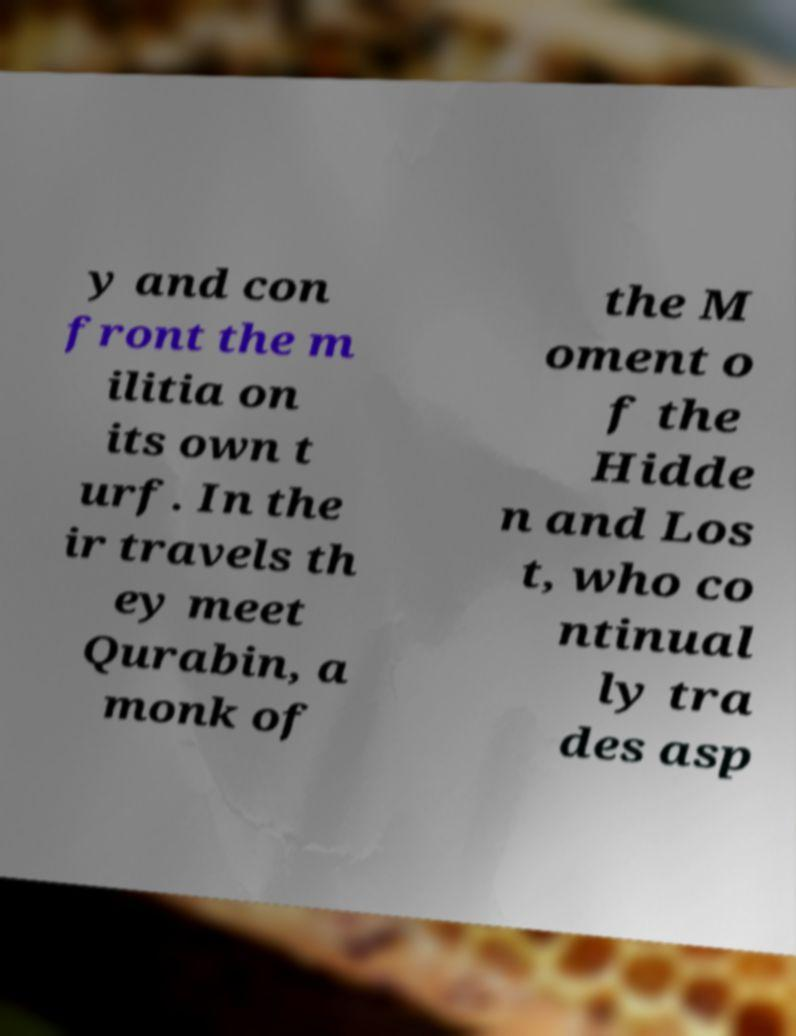Can you read and provide the text displayed in the image?This photo seems to have some interesting text. Can you extract and type it out for me? y and con front the m ilitia on its own t urf. In the ir travels th ey meet Qurabin, a monk of the M oment o f the Hidde n and Los t, who co ntinual ly tra des asp 